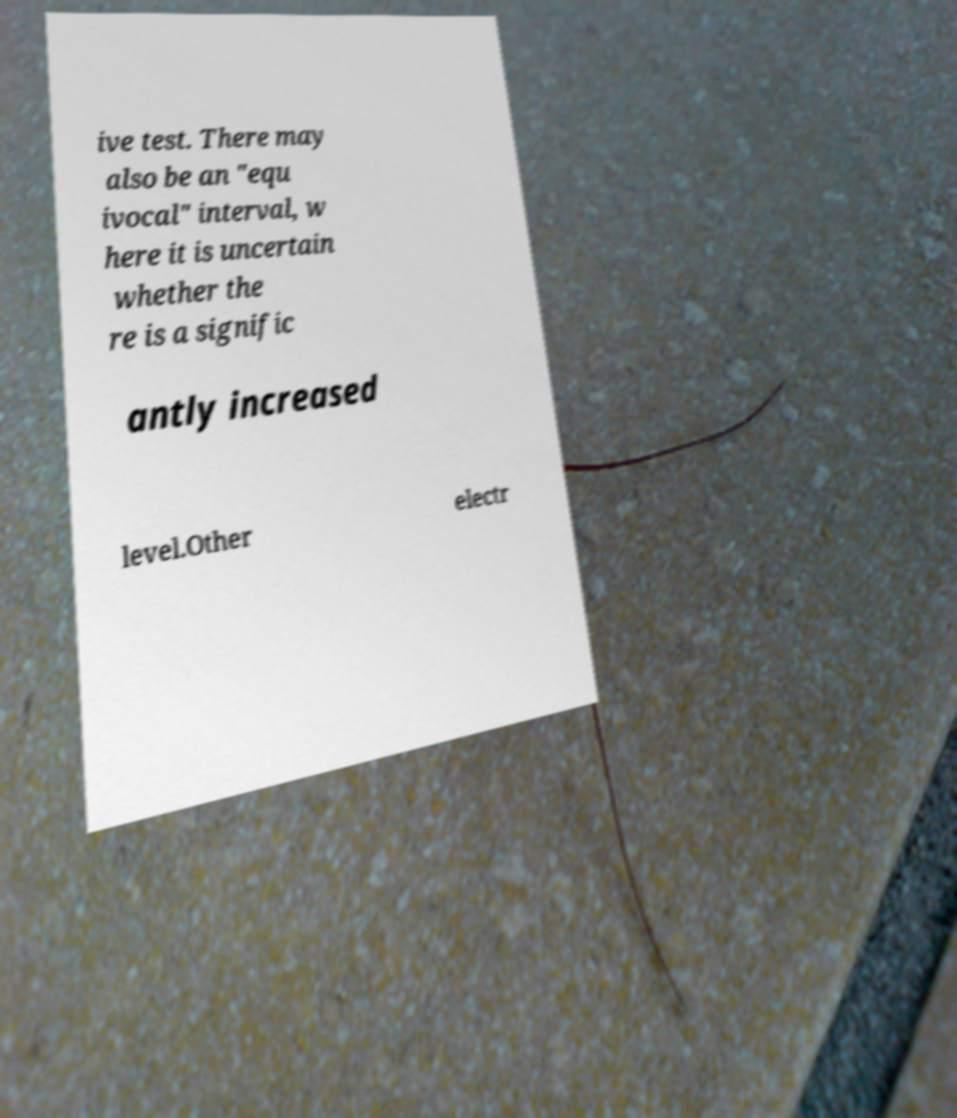Could you assist in decoding the text presented in this image and type it out clearly? ive test. There may also be an "equ ivocal" interval, w here it is uncertain whether the re is a signific antly increased level.Other electr 